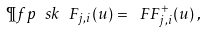Convert formula to latex. <formula><loc_0><loc_0><loc_500><loc_500>\P f p \ s k { \ F _ { j , i } ( u ) } = \ F F ^ { + } _ { j , i } ( u ) \, ,</formula> 